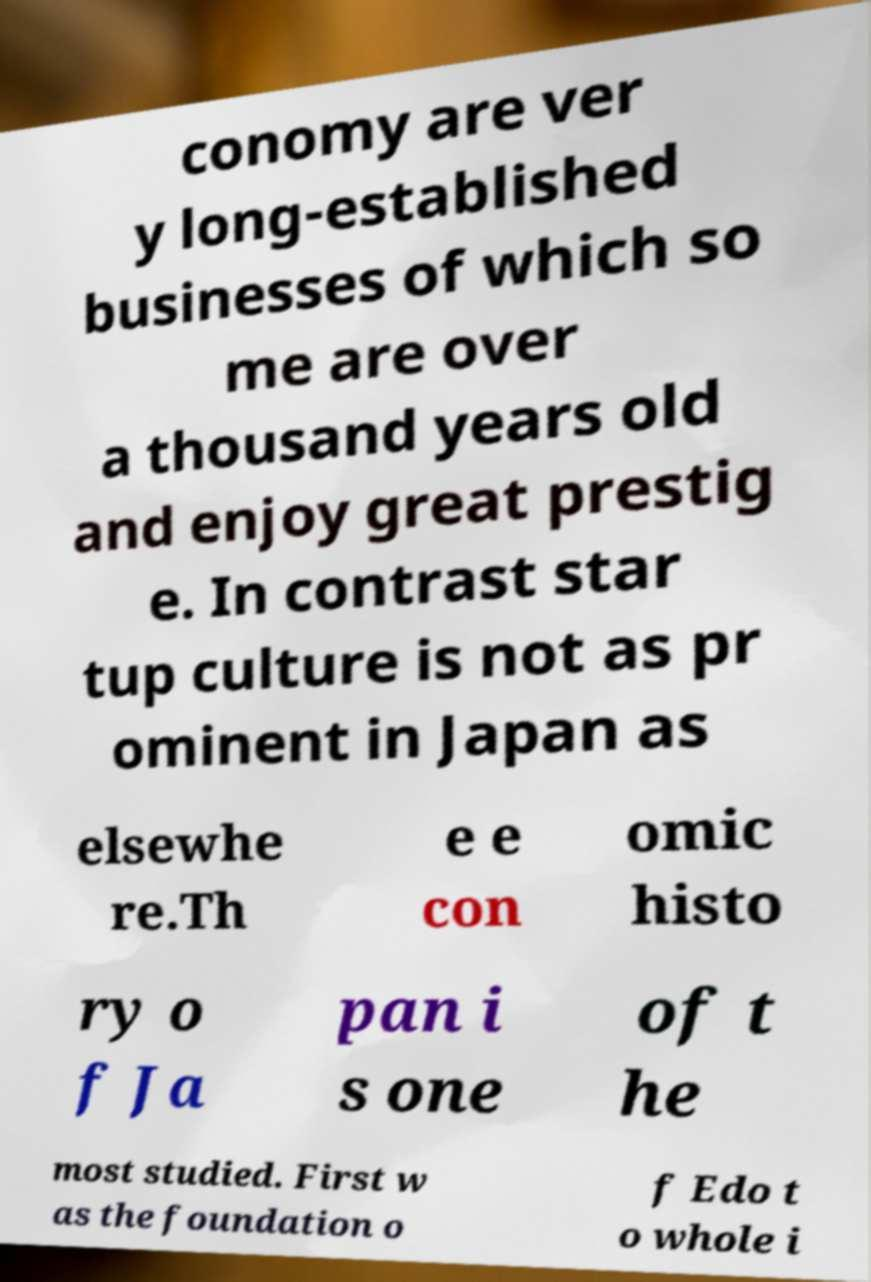Could you extract and type out the text from this image? conomy are ver y long-established businesses of which so me are over a thousand years old and enjoy great prestig e. In contrast star tup culture is not as pr ominent in Japan as elsewhe re.Th e e con omic histo ry o f Ja pan i s one of t he most studied. First w as the foundation o f Edo t o whole i 